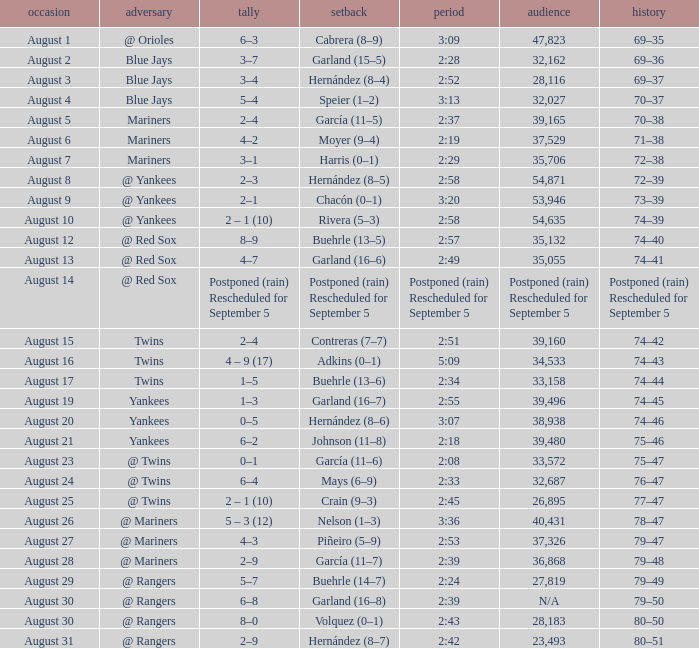Who lost with a time of 2:42? Hernández (8–7). 